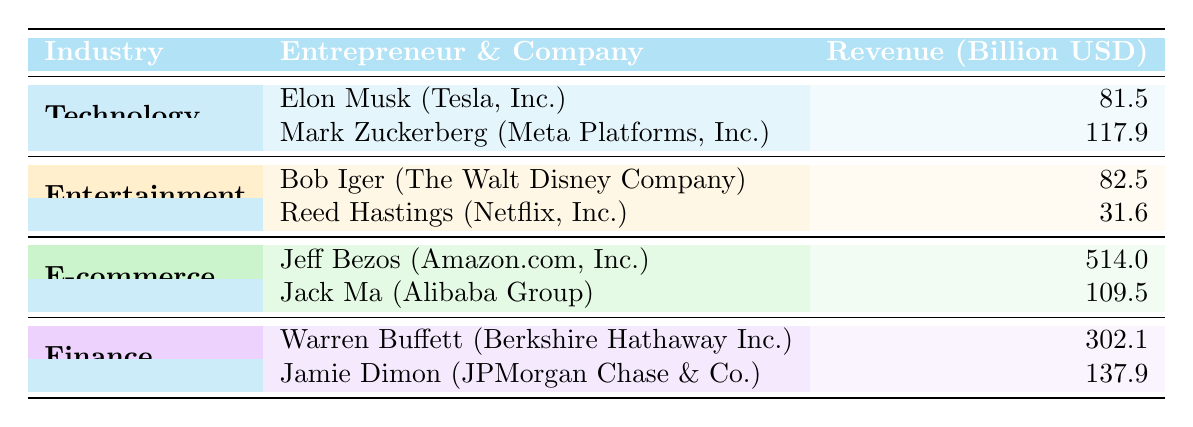What is the total revenue of the Technology industry? The Technology industry has two entrepreneurs: Elon Musk with a revenue of 81.5 billion USD and Mark Zuckerberg with a revenue of 117.9 billion USD. Adding these values gives: 81.5 + 117.9 = 199.4 billion USD.
Answer: 199.4 billion USD Who has the highest revenue in the E-commerce industry? In the E-commerce industry, there are two entrepreneurs: Jeff Bezos with a revenue of 514.0 billion USD and Jack Ma with a revenue of 109.5 billion USD. Jeff Bezos has the higher revenue.
Answer: Jeff Bezos Is the revenue of Reed Hastings higher than that of Jamie Dimon? Reed Hastings has a revenue of 31.6 billion USD, while Jamie Dimon has a revenue of 137.9 billion USD. Since 31.6 is less than 137.9, Reed Hastings' revenue is not higher.
Answer: No What is the average revenue of the entrepreneurs in the Finance industry? The Finance industry has two entrepreneurs: Warren Buffett with 302.1 billion USD and Jamie Dimon with 137.9 billion USD. To find the average, sum the revenues (302.1 + 137.9 = 440.0) and divide by the number of entrepreneurs (2). So, 440.0 / 2 = 220.0 billion USD.
Answer: 220.0 billion USD Which industry has the lowest total revenue among the entrepreneurs listed? We need to calculate the total revenue for each industry. Technology: 199.4 billion USD, Entertainment: 114.1 billion USD (82.5 + 31.6), E-commerce: 623.5 billion USD (514.0 + 109.5), and Finance: 440.0 billion USD. The Entertainment industry has the lowest total revenue of 114.1 billion USD.
Answer: Entertainment What percentage of the total revenue in the E-commerce industry does Jack Ma’s revenue represent? The total revenue in the E-commerce industry is 623.5 billion USD. Jack Ma’s revenue is 109.5 billion USD. To find the percentage, calculate (109.5 / 623.5) * 100 = 17.56%.
Answer: 17.56% Is there any entrepreneur in the table who has revenue over 500 billion USD? The highest revenue is 514.0 billion USD by Jeff Bezos, which is indeed over 500 billion USD.
Answer: Yes Who are the two entrepreneurs with the highest revenues collectively? The highest revenues belong to Jeff Bezos (514.0 billion USD) and Warren Buffett (302.1 billion USD). Their collective revenue is 514.0 + 302.1 = 816.1 billion USD, which makes them the two highest collectively.
Answer: Jeff Bezos and Warren Buffett 